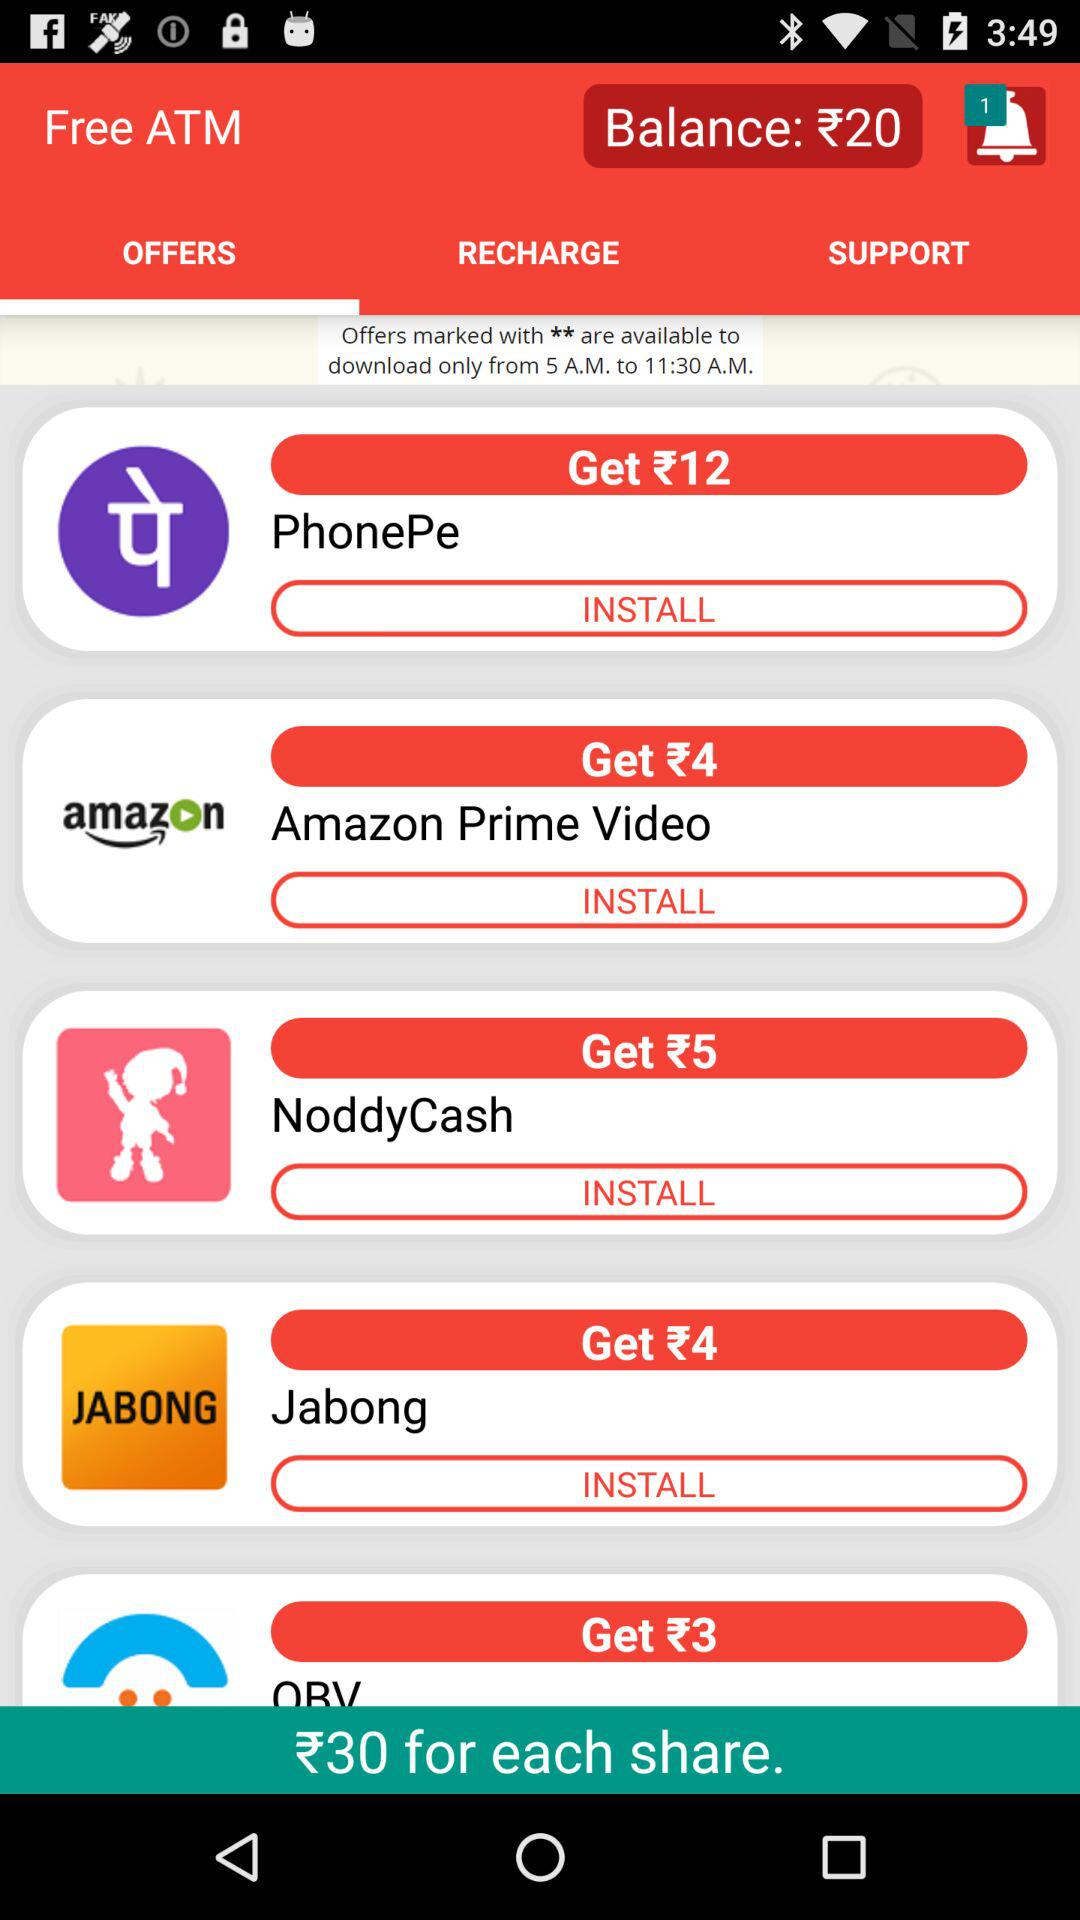How many offers are there in total?
Answer the question using a single word or phrase. 5 